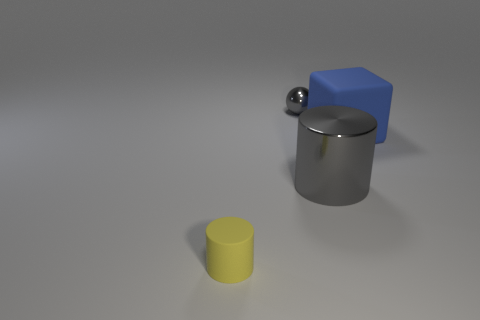What number of small yellow rubber things have the same shape as the blue object?
Your answer should be compact. 0. How many big metallic cylinders are there?
Your answer should be compact. 1. There is a thing that is left of the big metal object and in front of the big matte object; what is its size?
Offer a terse response. Small. What shape is the gray object that is the same size as the yellow rubber object?
Your response must be concise. Sphere. Is there a gray ball that is to the right of the tiny object that is behind the yellow object?
Offer a terse response. No. There is a rubber thing that is the same shape as the big gray shiny thing; what is its color?
Ensure brevity in your answer.  Yellow. There is a cylinder behind the yellow matte object; does it have the same color as the sphere?
Your response must be concise. Yes. What number of things are metal things that are in front of the gray metal sphere or tiny gray metallic objects?
Make the answer very short. 2. What is the material of the gray thing to the right of the object behind the big rubber cube that is behind the large gray metallic cylinder?
Provide a succinct answer. Metal. Is the number of big blue blocks that are on the left side of the blue object greater than the number of matte cylinders to the left of the tiny cylinder?
Offer a terse response. No. 